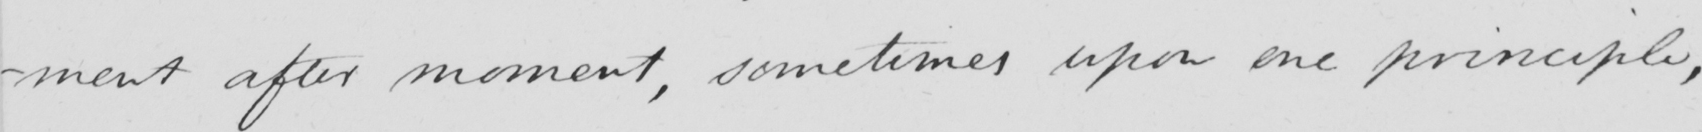What does this handwritten line say? -ment after moment, sometimes upon one principle, 